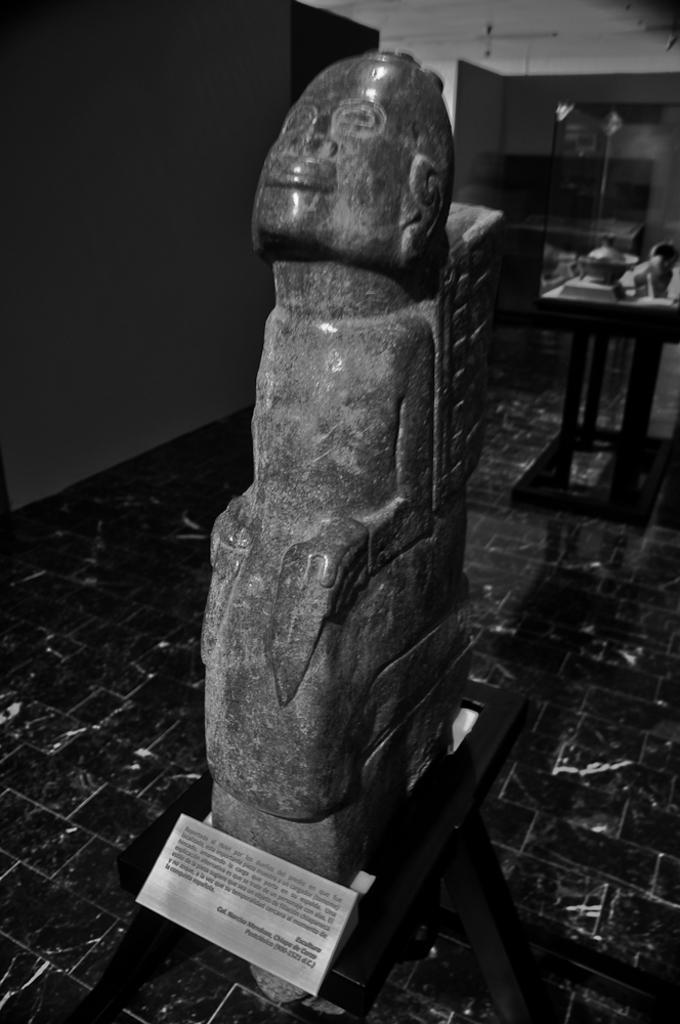Describe this image in one or two sentences. In this picture I can see a sculpture in the foreground. I can see the table. 